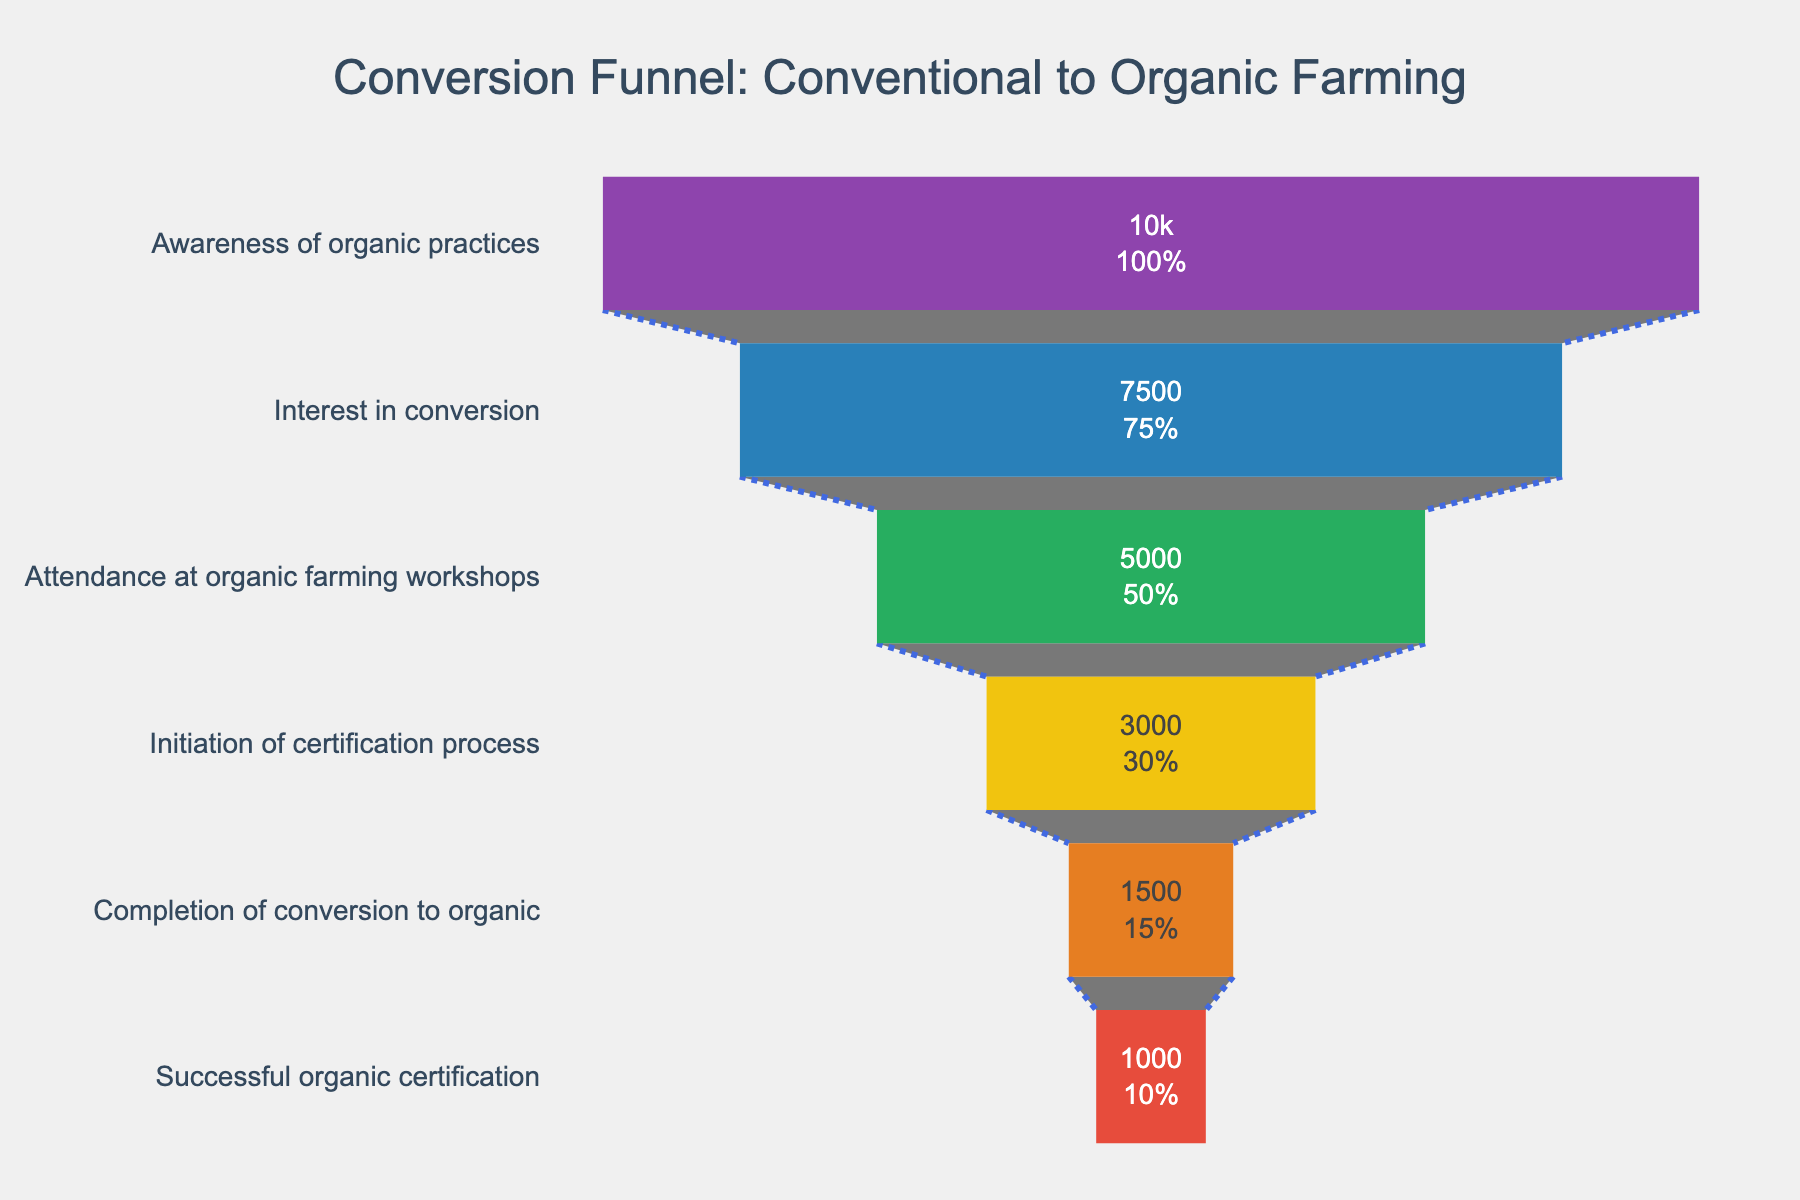What is the title of the funnel chart? The title is usually displayed at the top of the chart to provide a clear idea about what the chart represents. In this case, the title is given in the `title` section of the layout.
Answer: "Conversion Funnel: Conventional to Organic Farming" How many stages are there in the funnel chart? To determine this, count the number of distinct stages listed along the y-axis of the funnel chart. Each stage represents a step in the conversion process.
Answer: 6 What is the percentage of farmers who show interest in conversion after becoming aware of organic practices? The percentage can be read directly from the funnel chart's corresponding stage. Specifically, look for the stage labeled "Interest in conversion."
Answer: 75% How many farmers successfully complete the certification process? The number of farmers at each stage is displayed within the funnel chart. Look for the stage labeled "Successful organic certification."
Answer: 1000 How many farmers attend organic farming workshops? Check the number provided in the funnel chart for the stage labeled "Attendance at organic farming workshops."
Answer: 5000 What is the dropout rate from the stage "Interest in conversion" to "Attendance at organic farming workshops"? Calculate the dropout rate by subtracting the number of farmers in the second stage from the number of farmers in the first stage and then dividing by the initial number, expressed as a percentage. ((7500 - 5000) / 7500) * 100
Answer: 33.33% Which stage shows the highest number of farmers dropping out? To find this, look for the biggest difference in the number of farmers between consecutive stages.
Answer: Initiation of certification process to Completion of conversion to organic What percentage of farmers complete the conversion to organic farming out of those who initiate the certification process? Divide the number of farmers who complete the conversion by the number who initiate the certification process and multiply by 100. (1500 / 3000) * 100
Answer: 50% Which stage has the smallest percentage of drop-off from the previous stage? Compare the percentage drop-off between each pair of consecutive stages. The stage with the smallest difference has the lowest drop-off rate.
Answer: Awareness of organic practices to Interest in conversion What proportion of farmers who are aware of organic practices eventually get a successful organic certification? Calculate the percentage by dividing the final number of farmers by the initial number and multiplying by 100. (1000 / 10000) * 100
Answer: 10% 